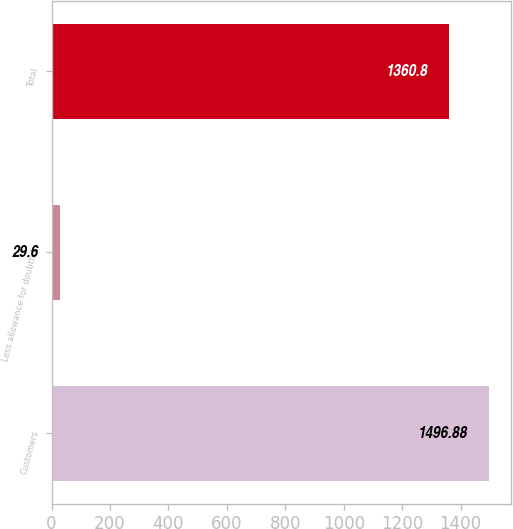Convert chart to OTSL. <chart><loc_0><loc_0><loc_500><loc_500><bar_chart><fcel>Customers<fcel>Less allowance for doubtful<fcel>Total<nl><fcel>1496.88<fcel>29.6<fcel>1360.8<nl></chart> 